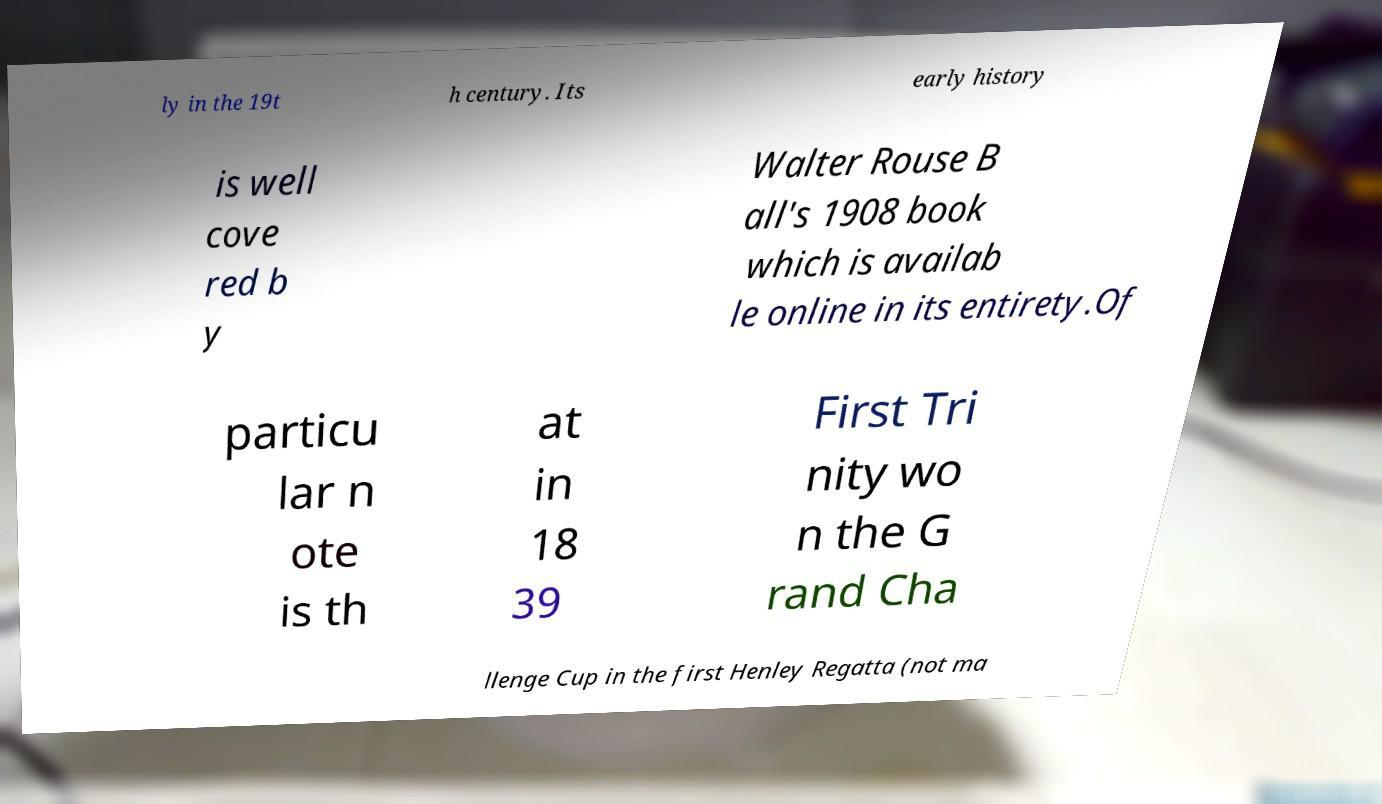What messages or text are displayed in this image? I need them in a readable, typed format. ly in the 19t h century. Its early history is well cove red b y Walter Rouse B all's 1908 book which is availab le online in its entirety.Of particu lar n ote is th at in 18 39 First Tri nity wo n the G rand Cha llenge Cup in the first Henley Regatta (not ma 